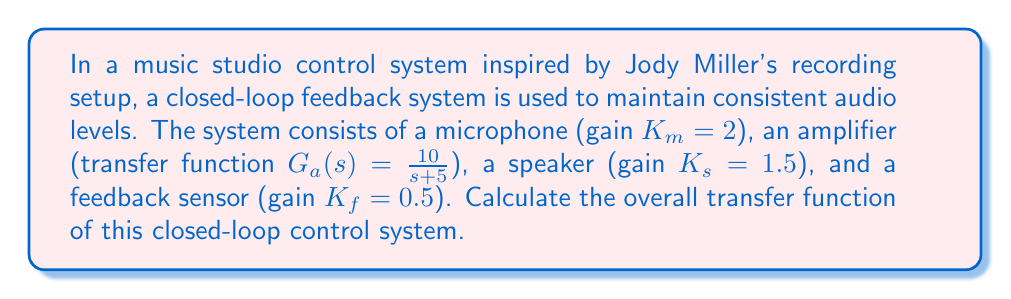Help me with this question. To solve this problem, we'll follow these steps:

1) First, let's identify the components of the system:
   - Plant (amplifier): $G_a(s) = \frac{10}{s+5}$
   - Forward path gain: $K = K_m \cdot K_s = 2 \cdot 1.5 = 3$
   - Feedback gain: $K_f = 0.5$

2) The general form of a closed-loop transfer function is:

   $$T(s) = \frac{KG(s)}{1 + KG(s)H(s)}$$

   where $KG(s)$ is the forward path transfer function and $H(s)$ is the feedback transfer function.

3) In our case:
   $KG(s) = K \cdot G_a(s) = 3 \cdot \frac{10}{s+5} = \frac{30}{s+5}$
   $H(s) = K_f = 0.5$

4) Substituting these into the closed-loop transfer function formula:

   $$T(s) = \frac{\frac{30}{s+5}}{1 + \frac{30}{s+5} \cdot 0.5}$$

5) Simplify the denominator:
   $$T(s) = \frac{\frac{30}{s+5}}{1 + \frac{15}{s+5}} = \frac{\frac{30}{s+5}}{\frac{s+5}{s+5} + \frac{15}{s+5}} = \frac{\frac{30}{s+5}}{\frac{s+20}{s+5}}$$

6) Multiply both numerator and denominator by $(s+5)$:

   $$T(s) = \frac{30}{s+20}$$

This is the final closed-loop transfer function of the system.
Answer: $$T(s) = \frac{30}{s+20}$$ 